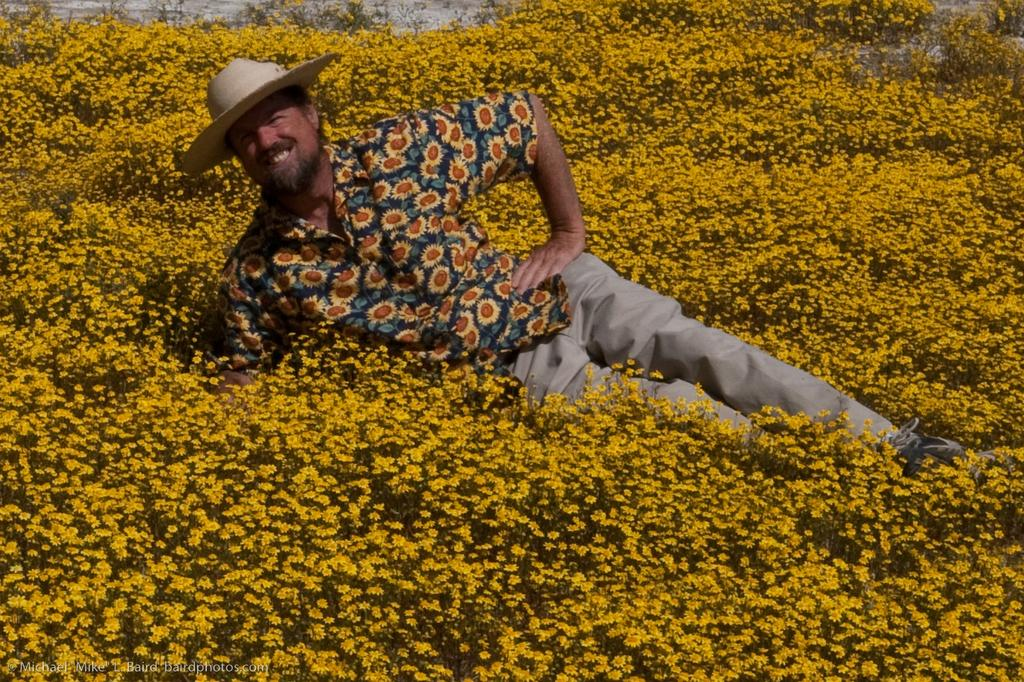What is present in the image? There is a person in the image. What is the person wearing? The person is wearing a shirt and a hat. Where is the person located in the image? The person is lying on a flower garden. What type of lumber is the person using to build a fence in the image? There is no lumber or fence present in the image; the person is lying on a flower garden. 